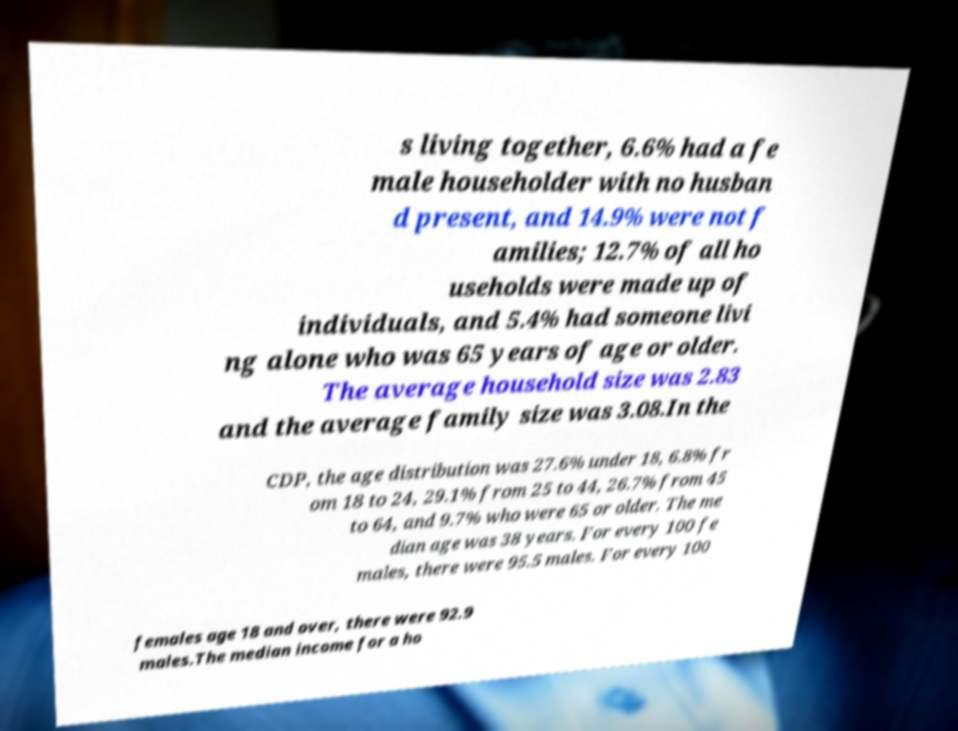Please read and relay the text visible in this image. What does it say? s living together, 6.6% had a fe male householder with no husban d present, and 14.9% were not f amilies; 12.7% of all ho useholds were made up of individuals, and 5.4% had someone livi ng alone who was 65 years of age or older. The average household size was 2.83 and the average family size was 3.08.In the CDP, the age distribution was 27.6% under 18, 6.8% fr om 18 to 24, 29.1% from 25 to 44, 26.7% from 45 to 64, and 9.7% who were 65 or older. The me dian age was 38 years. For every 100 fe males, there were 95.5 males. For every 100 females age 18 and over, there were 92.9 males.The median income for a ho 